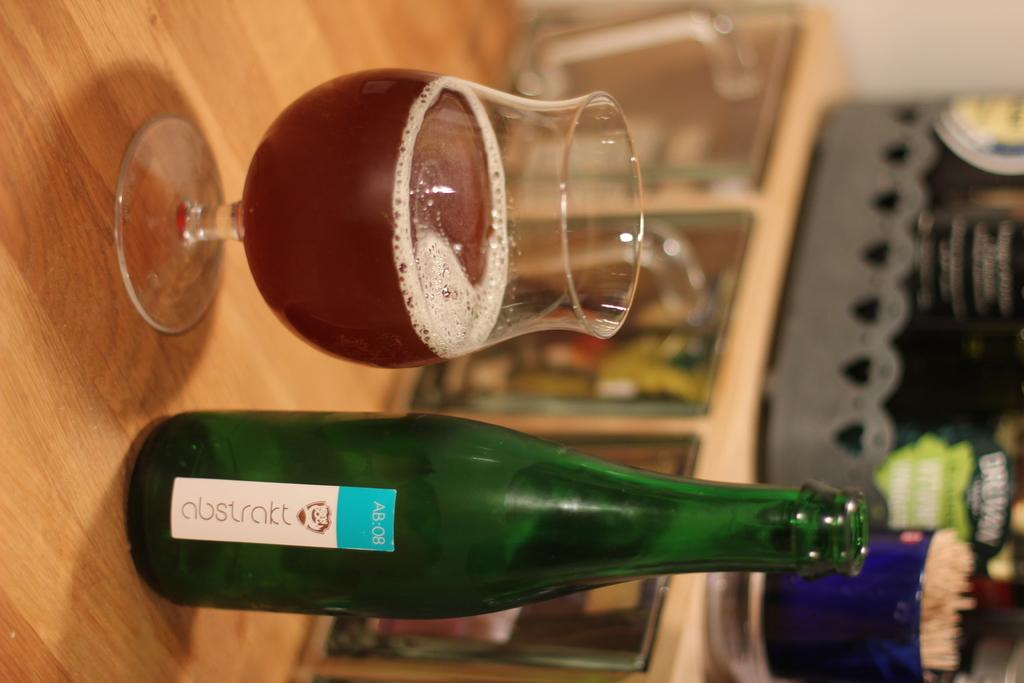<image>
Relay a brief, clear account of the picture shown. A green bottle of abstrakt sits next to a stemmed glass that is half ful. 